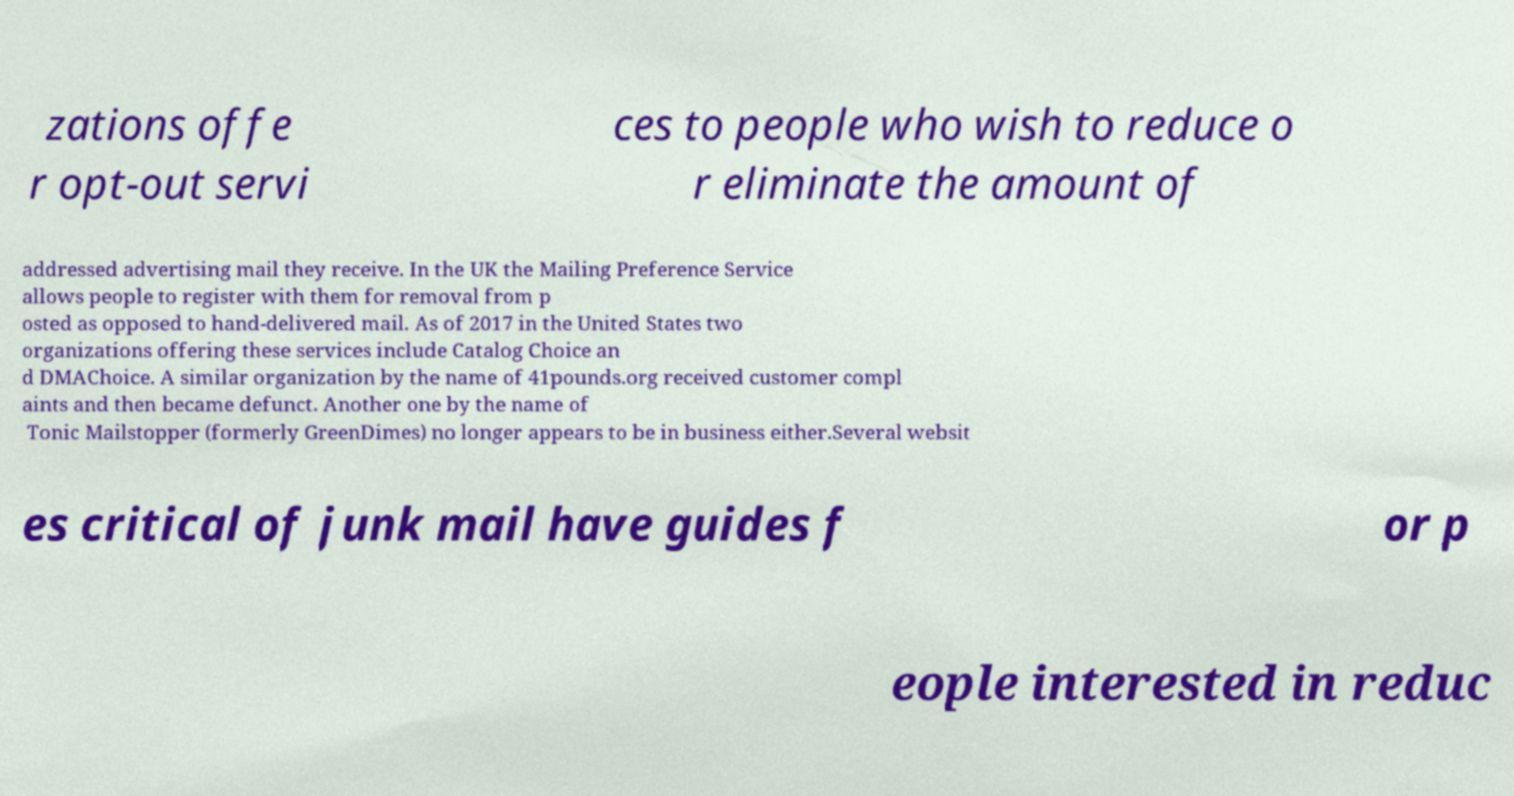Could you assist in decoding the text presented in this image and type it out clearly? zations offe r opt-out servi ces to people who wish to reduce o r eliminate the amount of addressed advertising mail they receive. In the UK the Mailing Preference Service allows people to register with them for removal from p osted as opposed to hand-delivered mail. As of 2017 in the United States two organizations offering these services include Catalog Choice an d DMAChoice. A similar organization by the name of 41pounds.org received customer compl aints and then became defunct. Another one by the name of Tonic Mailstopper (formerly GreenDimes) no longer appears to be in business either.Several websit es critical of junk mail have guides f or p eople interested in reduc 